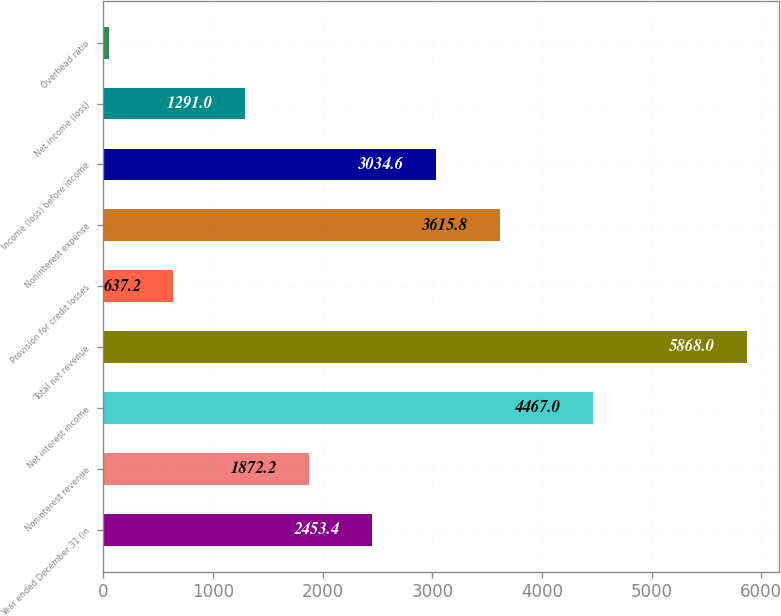Convert chart to OTSL. <chart><loc_0><loc_0><loc_500><loc_500><bar_chart><fcel>Year ended December 31 (in<fcel>Noninterest revenue<fcel>Net interest income<fcel>Total net revenue<fcel>Provision for credit losses<fcel>Noninterest expense<fcel>Income (loss) before income<fcel>Net income (loss)<fcel>Overhead ratio<nl><fcel>2453.4<fcel>1872.2<fcel>4467<fcel>5868<fcel>637.2<fcel>3615.8<fcel>3034.6<fcel>1291<fcel>56<nl></chart> 